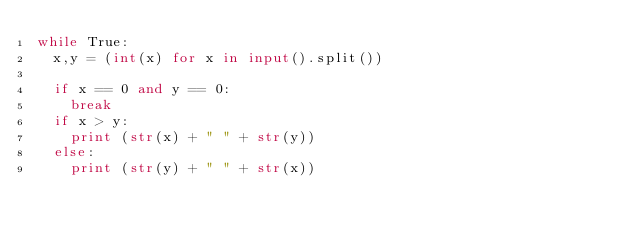<code> <loc_0><loc_0><loc_500><loc_500><_Python_>while True:
  x,y = (int(x) for x in input().split())

  if x == 0 and y == 0:
    break
  if x > y:
    print (str(x) + " " + str(y))
  else:
    print (str(y) + " " + str(x))
</code> 